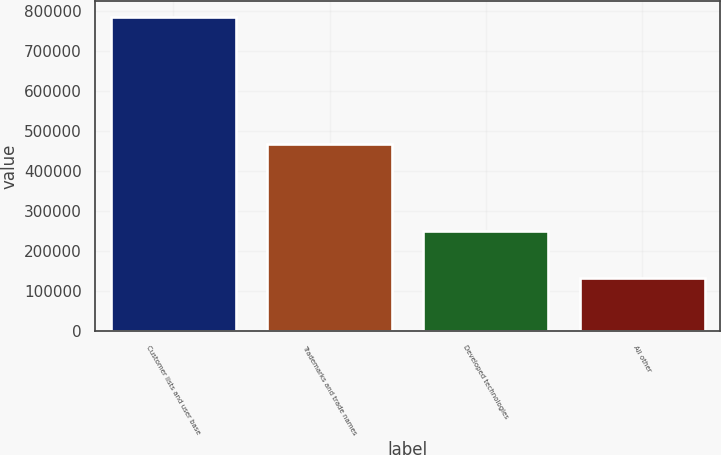Convert chart. <chart><loc_0><loc_0><loc_500><loc_500><bar_chart><fcel>Customer lists and user base<fcel>Trademarks and trade names<fcel>Developed technologies<fcel>All other<nl><fcel>786623<fcel>468905<fcel>249228<fcel>131832<nl></chart> 